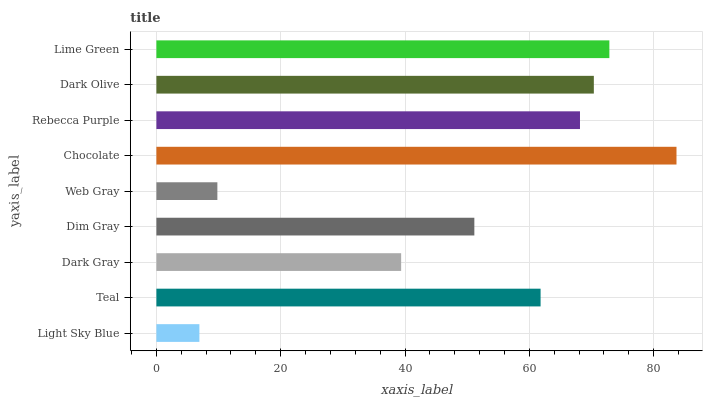Is Light Sky Blue the minimum?
Answer yes or no. Yes. Is Chocolate the maximum?
Answer yes or no. Yes. Is Teal the minimum?
Answer yes or no. No. Is Teal the maximum?
Answer yes or no. No. Is Teal greater than Light Sky Blue?
Answer yes or no. Yes. Is Light Sky Blue less than Teal?
Answer yes or no. Yes. Is Light Sky Blue greater than Teal?
Answer yes or no. No. Is Teal less than Light Sky Blue?
Answer yes or no. No. Is Teal the high median?
Answer yes or no. Yes. Is Teal the low median?
Answer yes or no. Yes. Is Chocolate the high median?
Answer yes or no. No. Is Dark Gray the low median?
Answer yes or no. No. 